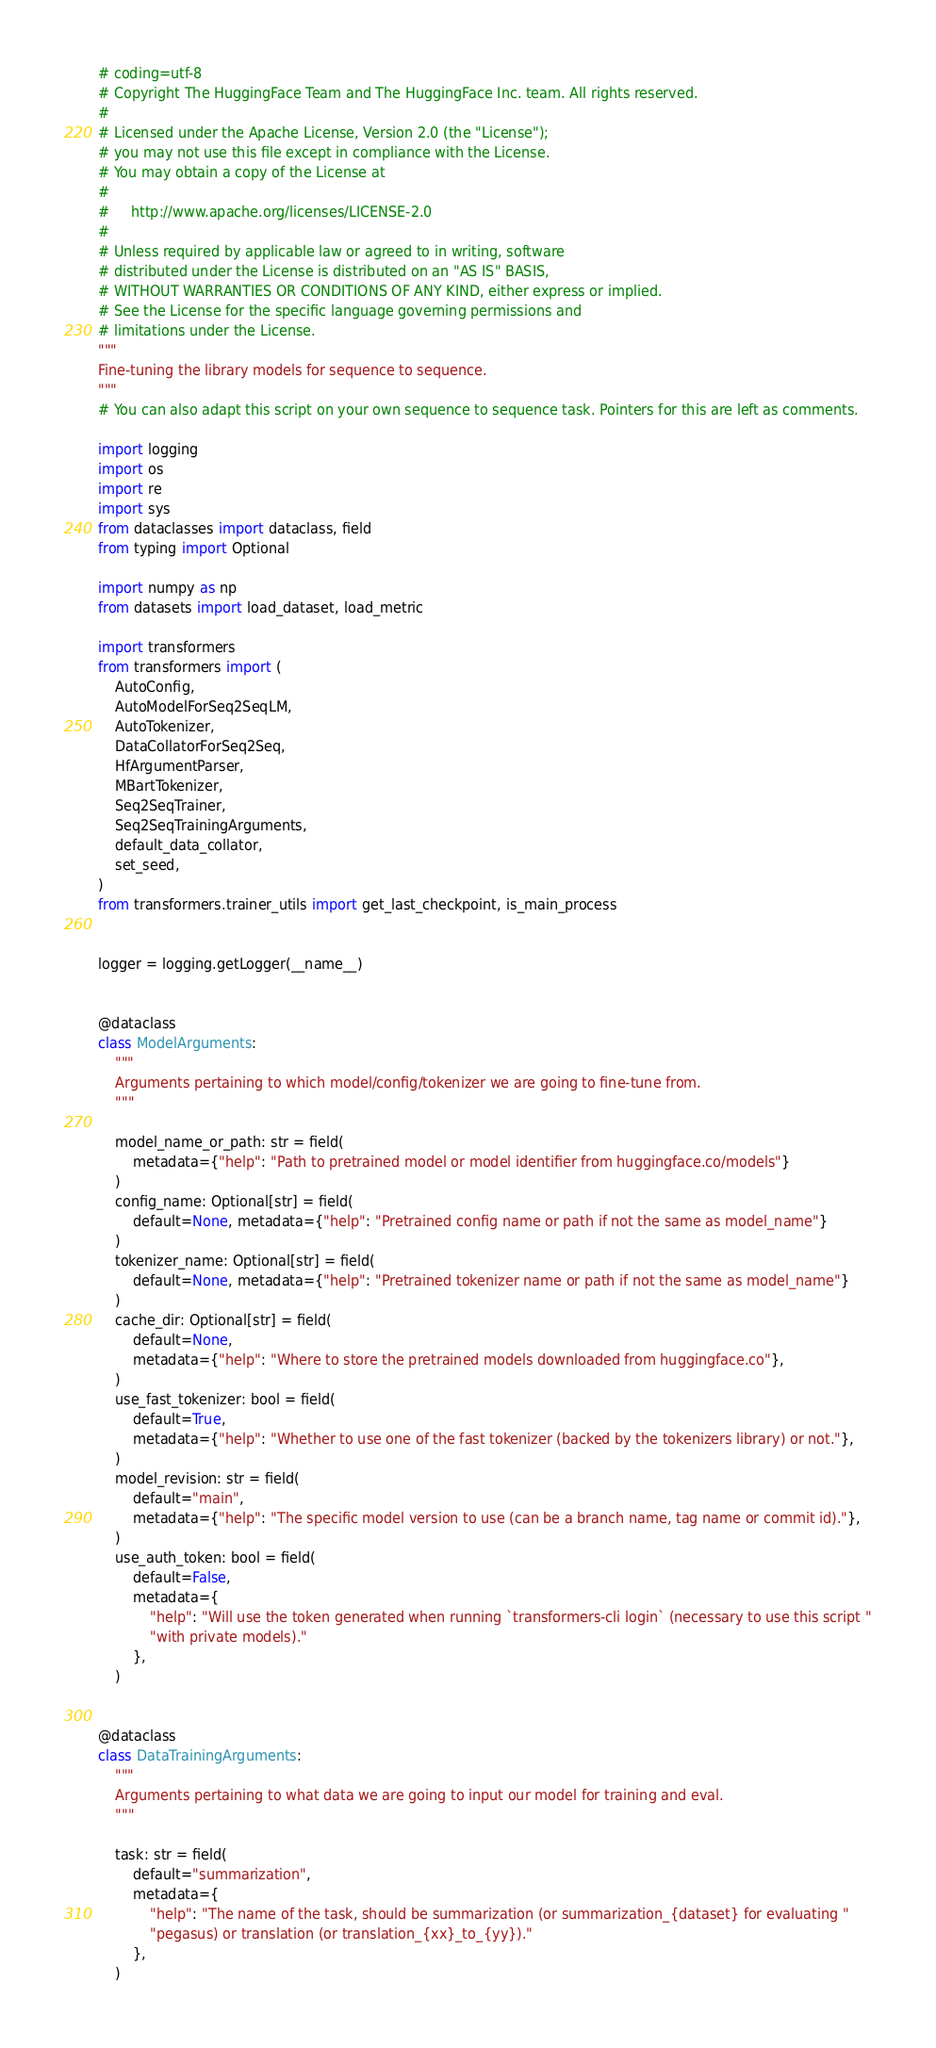<code> <loc_0><loc_0><loc_500><loc_500><_Python_># coding=utf-8
# Copyright The HuggingFace Team and The HuggingFace Inc. team. All rights reserved.
#
# Licensed under the Apache License, Version 2.0 (the "License");
# you may not use this file except in compliance with the License.
# You may obtain a copy of the License at
#
#     http://www.apache.org/licenses/LICENSE-2.0
#
# Unless required by applicable law or agreed to in writing, software
# distributed under the License is distributed on an "AS IS" BASIS,
# WITHOUT WARRANTIES OR CONDITIONS OF ANY KIND, either express or implied.
# See the License for the specific language governing permissions and
# limitations under the License.
"""
Fine-tuning the library models for sequence to sequence.
"""
# You can also adapt this script on your own sequence to sequence task. Pointers for this are left as comments.

import logging
import os
import re
import sys
from dataclasses import dataclass, field
from typing import Optional

import numpy as np
from datasets import load_dataset, load_metric

import transformers
from transformers import (
    AutoConfig,
    AutoModelForSeq2SeqLM,
    AutoTokenizer,
    DataCollatorForSeq2Seq,
    HfArgumentParser,
    MBartTokenizer,
    Seq2SeqTrainer,
    Seq2SeqTrainingArguments,
    default_data_collator,
    set_seed,
)
from transformers.trainer_utils import get_last_checkpoint, is_main_process


logger = logging.getLogger(__name__)


@dataclass
class ModelArguments:
    """
    Arguments pertaining to which model/config/tokenizer we are going to fine-tune from.
    """

    model_name_or_path: str = field(
        metadata={"help": "Path to pretrained model or model identifier from huggingface.co/models"}
    )
    config_name: Optional[str] = field(
        default=None, metadata={"help": "Pretrained config name or path if not the same as model_name"}
    )
    tokenizer_name: Optional[str] = field(
        default=None, metadata={"help": "Pretrained tokenizer name or path if not the same as model_name"}
    )
    cache_dir: Optional[str] = field(
        default=None,
        metadata={"help": "Where to store the pretrained models downloaded from huggingface.co"},
    )
    use_fast_tokenizer: bool = field(
        default=True,
        metadata={"help": "Whether to use one of the fast tokenizer (backed by the tokenizers library) or not."},
    )
    model_revision: str = field(
        default="main",
        metadata={"help": "The specific model version to use (can be a branch name, tag name or commit id)."},
    )
    use_auth_token: bool = field(
        default=False,
        metadata={
            "help": "Will use the token generated when running `transformers-cli login` (necessary to use this script "
            "with private models)."
        },
    )


@dataclass
class DataTrainingArguments:
    """
    Arguments pertaining to what data we are going to input our model for training and eval.
    """

    task: str = field(
        default="summarization",
        metadata={
            "help": "The name of the task, should be summarization (or summarization_{dataset} for evaluating "
            "pegasus) or translation (or translation_{xx}_to_{yy})."
        },
    )</code> 